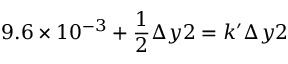<formula> <loc_0><loc_0><loc_500><loc_500>9 . 6 \times 1 0 ^ { - 3 } + \frac { 1 } { 2 } \Delta y 2 = k ^ { \prime } \Delta y 2</formula> 